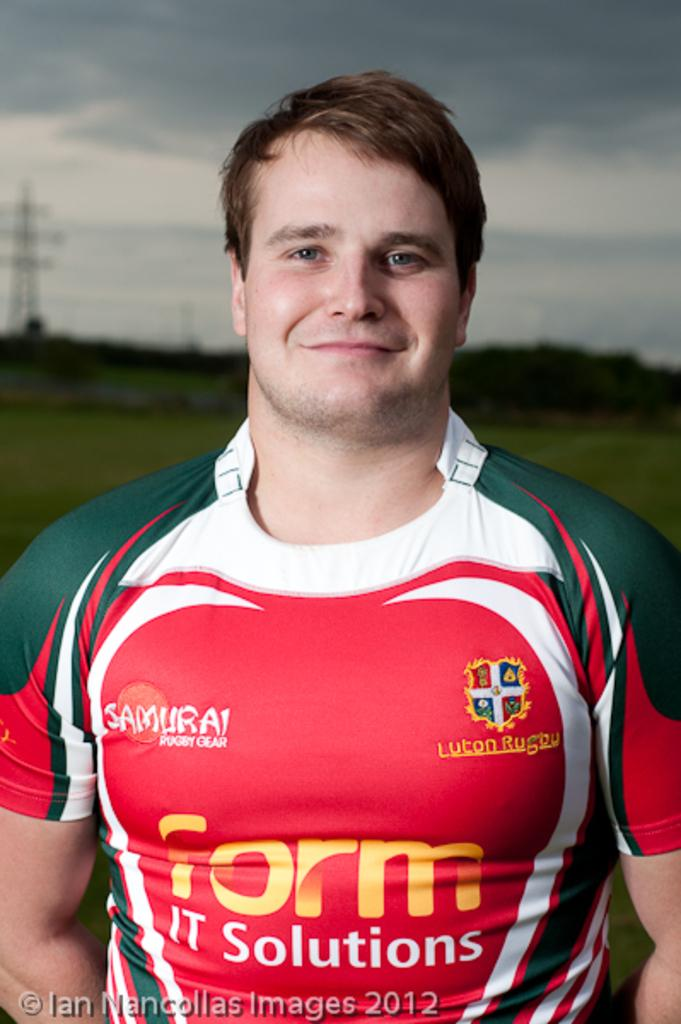<image>
Give a short and clear explanation of the subsequent image. a man wearing a shirt that says 'form IT solutions' on it 